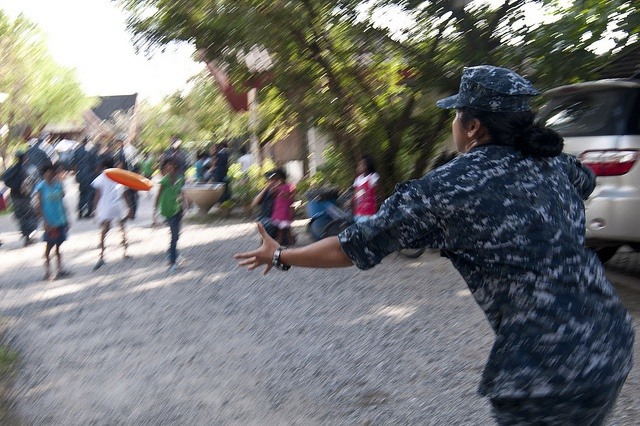Describe the objects in this image and their specific colors. I can see people in white, black, navy, gray, and darkblue tones, car in white, black, darkgray, gray, and lightgray tones, people in white, lavender, darkgray, and gray tones, people in white, gray, teal, and black tones, and people in white, black, and gray tones in this image. 